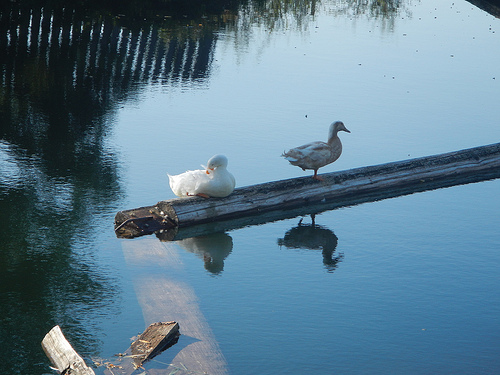<image>
Is there a reflection behind the log? No. The reflection is not behind the log. From this viewpoint, the reflection appears to be positioned elsewhere in the scene. Where is the duck in relation to the water? Is it in the water? No. The duck is not contained within the water. These objects have a different spatial relationship. Is the duck in front of the duck? No. The duck is not in front of the duck. The spatial positioning shows a different relationship between these objects. 